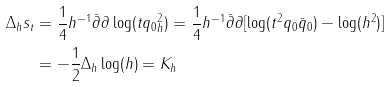<formula> <loc_0><loc_0><loc_500><loc_500>\Delta _ { h } s _ { t } & = \frac { 1 } { 4 } h ^ { - 1 } \bar { \partial } \partial \log ( \| t q _ { 0 } \| _ { h } ^ { 2 } ) = \frac { 1 } { 4 } h ^ { - 1 } \bar { \partial } \partial [ \log ( t ^ { 2 } q _ { 0 } \bar { q } _ { 0 } ) - \log ( h ^ { 2 } ) ] \\ & = - \frac { 1 } { 2 } \Delta _ { h } \log ( h ) = K _ { h }</formula> 